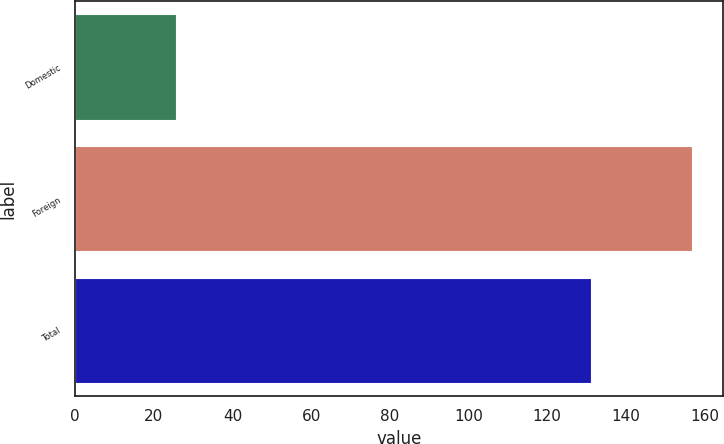Convert chart to OTSL. <chart><loc_0><loc_0><loc_500><loc_500><bar_chart><fcel>Domestic<fcel>Foreign<fcel>Total<nl><fcel>25.7<fcel>156.8<fcel>131.1<nl></chart> 